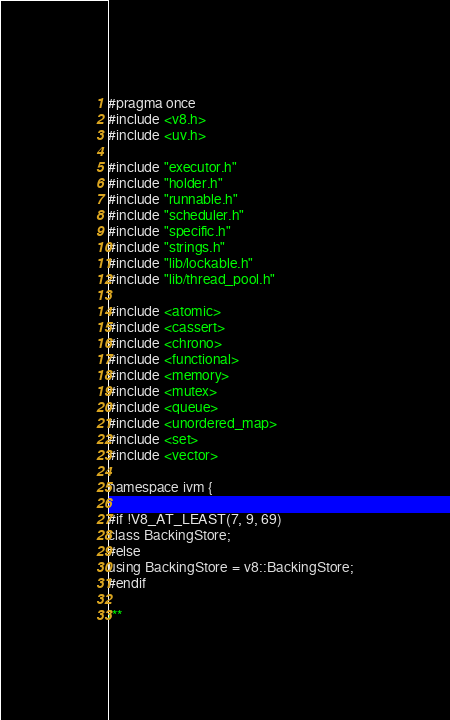<code> <loc_0><loc_0><loc_500><loc_500><_C_>#pragma once
#include <v8.h>
#include <uv.h>

#include "executor.h"
#include "holder.h"
#include "runnable.h"
#include "scheduler.h"
#include "specific.h"
#include "strings.h"
#include "lib/lockable.h"
#include "lib/thread_pool.h"

#include <atomic>
#include <cassert>
#include <chrono>
#include <functional>
#include <memory>
#include <mutex>
#include <queue>
#include <unordered_map>
#include <set>
#include <vector>

namespace ivm {

#if !V8_AT_LEAST(7, 9, 69)
class BackingStore;
#else
using BackingStore = v8::BackingStore;
#endif

/**</code> 